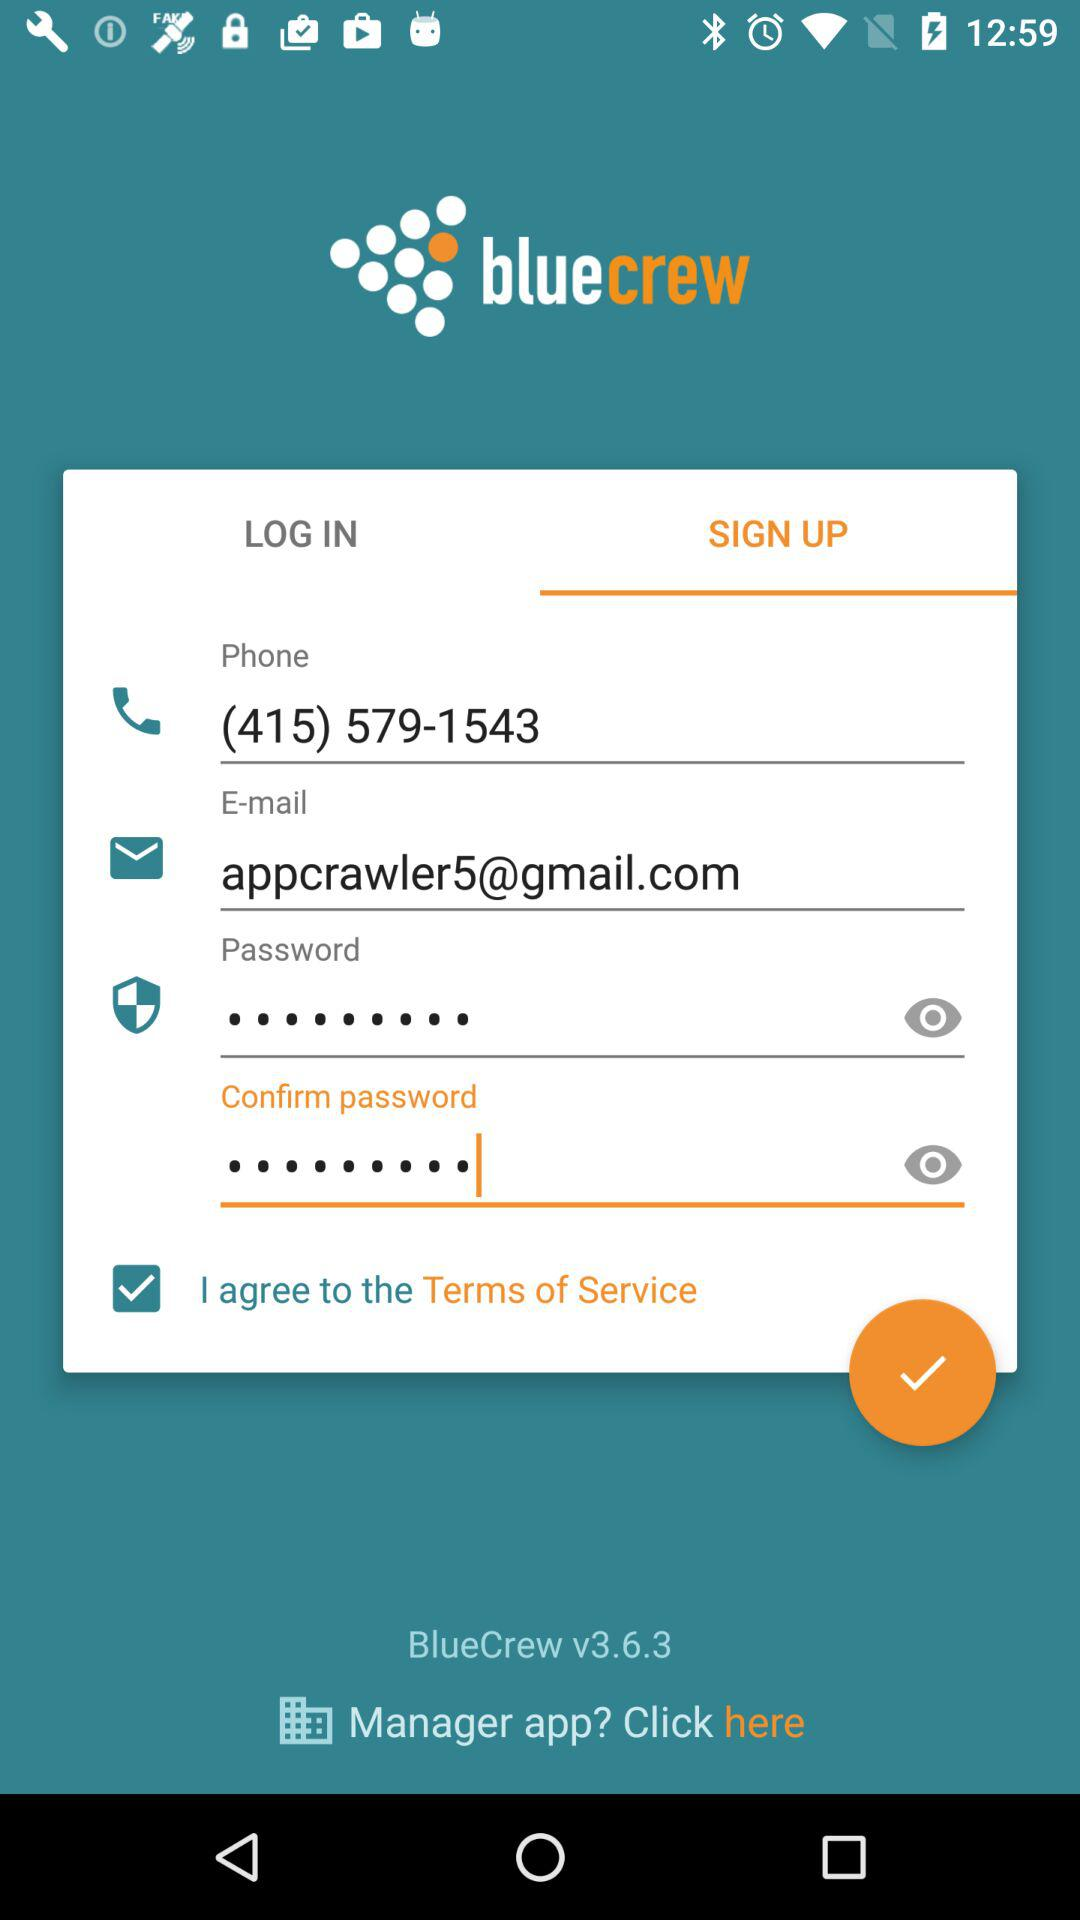What is the application name? The application name is "bluecrew". 